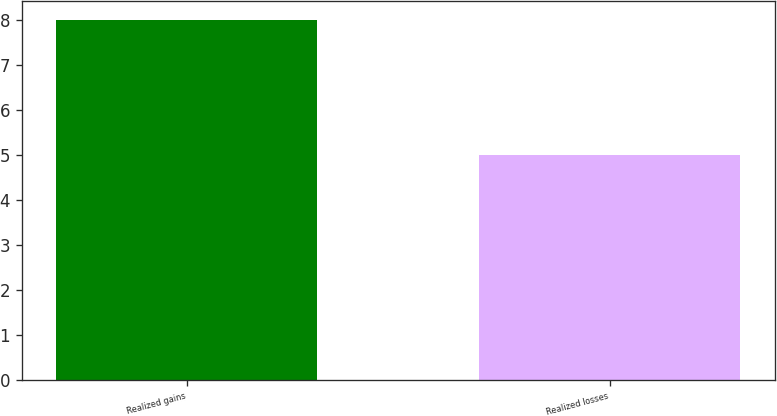Convert chart to OTSL. <chart><loc_0><loc_0><loc_500><loc_500><bar_chart><fcel>Realized gains<fcel>Realized losses<nl><fcel>8<fcel>5<nl></chart> 